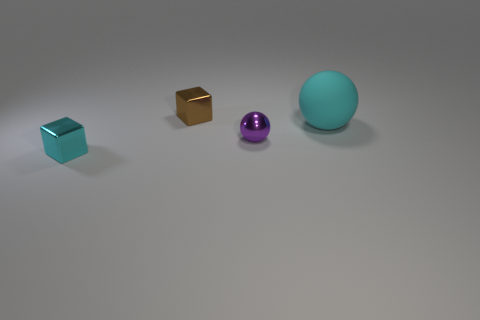There is another small thing that is the same shape as the brown object; what is it made of?
Keep it short and to the point. Metal. Is there any other thing that is the same size as the matte object?
Your response must be concise. No. There is a block behind the small cube in front of the cyan matte sphere; how big is it?
Your answer should be very brief. Small. The small metal ball is what color?
Keep it short and to the point. Purple. There is a tiny cube that is in front of the large cyan rubber ball; how many small spheres are behind it?
Ensure brevity in your answer.  1. Are there any tiny cubes that are in front of the metal thing behind the tiny purple metallic sphere?
Offer a terse response. Yes. Are there any spheres on the right side of the small purple sphere?
Keep it short and to the point. Yes. Do the thing that is behind the large matte thing and the tiny cyan metal object have the same shape?
Give a very brief answer. Yes. How many other things have the same shape as the small brown metallic object?
Offer a very short reply. 1. Is there a big gray cube made of the same material as the large sphere?
Your response must be concise. No. 